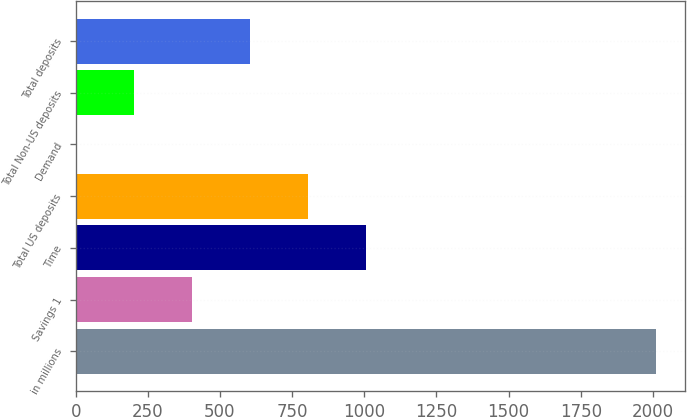<chart> <loc_0><loc_0><loc_500><loc_500><bar_chart><fcel>in millions<fcel>Savings 1<fcel>Time<fcel>Total US deposits<fcel>Demand<fcel>Total Non-US deposits<fcel>Total deposits<nl><fcel>2010<fcel>402.28<fcel>1005.19<fcel>804.22<fcel>0.34<fcel>201.31<fcel>603.25<nl></chart> 